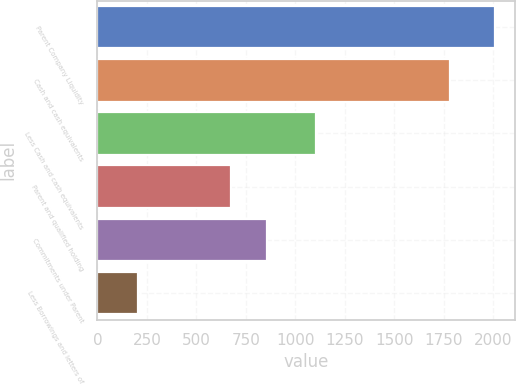Convert chart to OTSL. <chart><loc_0><loc_0><loc_500><loc_500><bar_chart><fcel>Parent Company Liquidity<fcel>Cash and cash equivalents<fcel>Less Cash and cash equivalents<fcel>Parent and qualified holding<fcel>Commitments under Parent<fcel>Less Borrowings and letters of<nl><fcel>2009<fcel>1782<fcel>1105<fcel>677<fcel>857.5<fcel>204<nl></chart> 